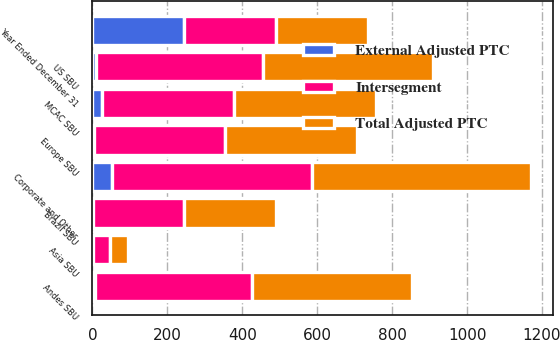<chart> <loc_0><loc_0><loc_500><loc_500><stacked_bar_chart><ecel><fcel>Year Ended December 31<fcel>US SBU<fcel>Andes SBU<fcel>Brazil SBU<fcel>MCAC SBU<fcel>Europe SBU<fcel>Asia SBU<fcel>Corporate and Other<nl><fcel>Intersegment<fcel>245<fcel>445<fcel>421<fcel>242<fcel>352<fcel>348<fcel>46<fcel>533<nl><fcel>External Adjusted PTC<fcel>245<fcel>10<fcel>6<fcel>3<fcel>26<fcel>5<fcel>2<fcel>52<nl><fcel>Total Adjusted PTC<fcel>245<fcel>455<fcel>427<fcel>245<fcel>378<fcel>353<fcel>48<fcel>585<nl></chart> 